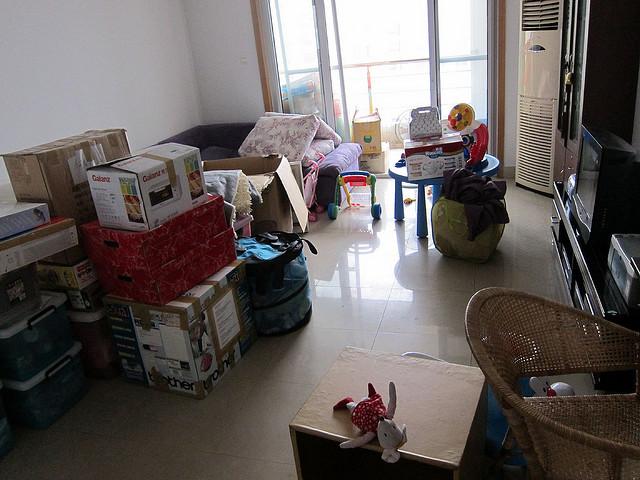Where are the two blue coolers?
Short answer required. Left. What kind of room is this?
Short answer required. Living room. Are they moving?
Concise answer only. Yes. 